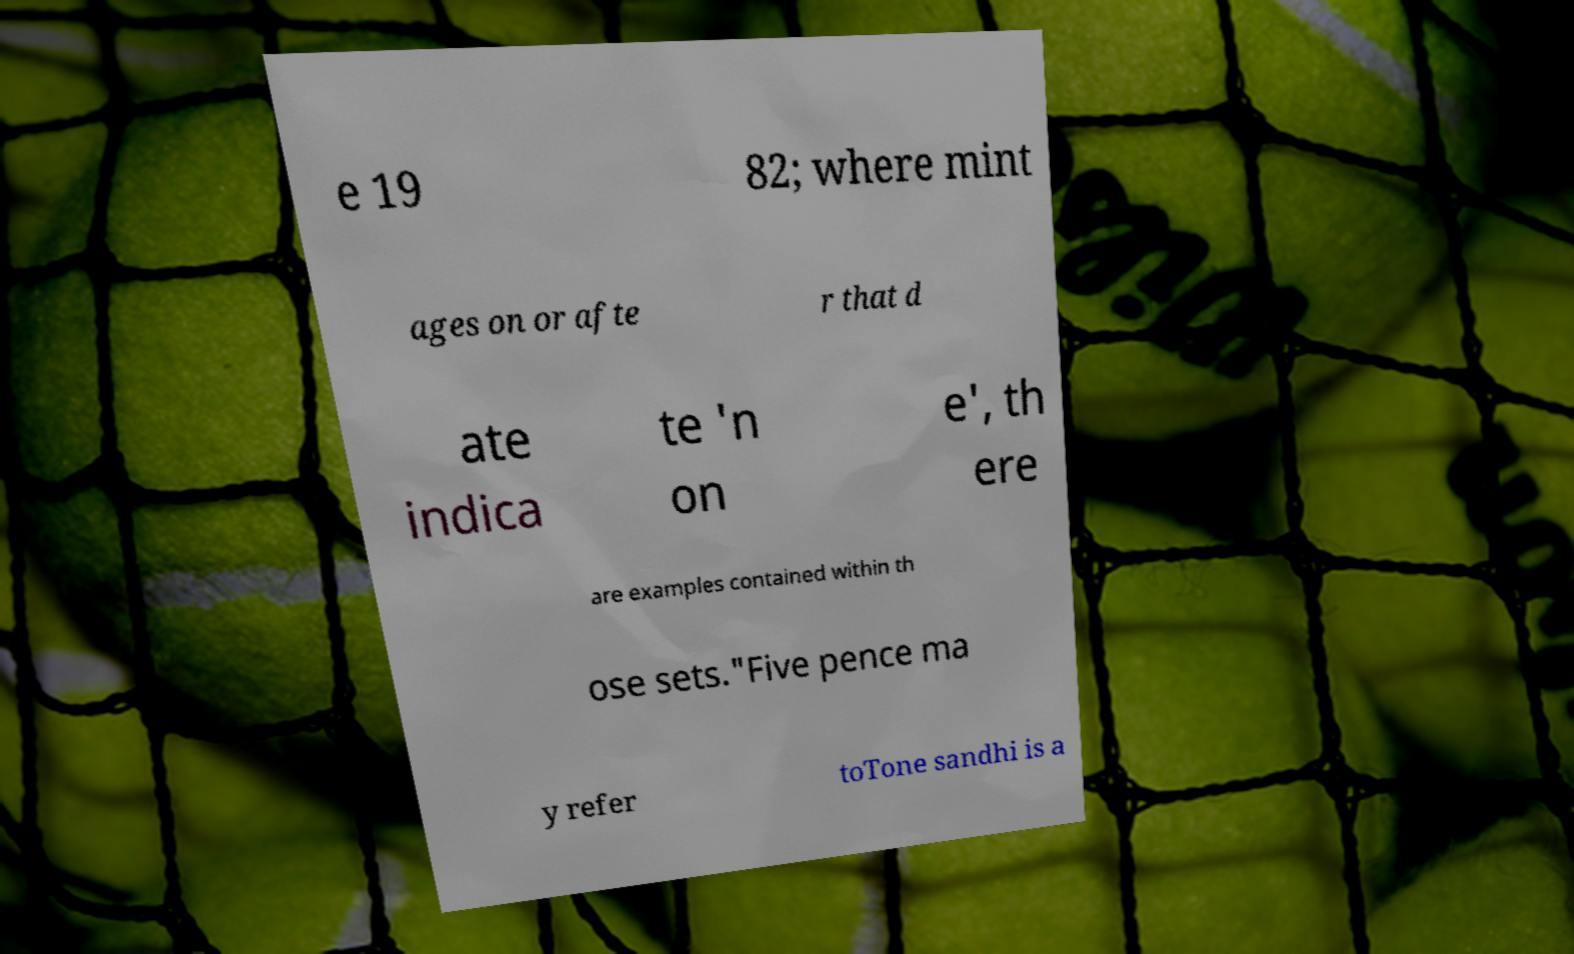I need the written content from this picture converted into text. Can you do that? e 19 82; where mint ages on or afte r that d ate indica te 'n on e', th ere are examples contained within th ose sets."Five pence ma y refer toTone sandhi is a 